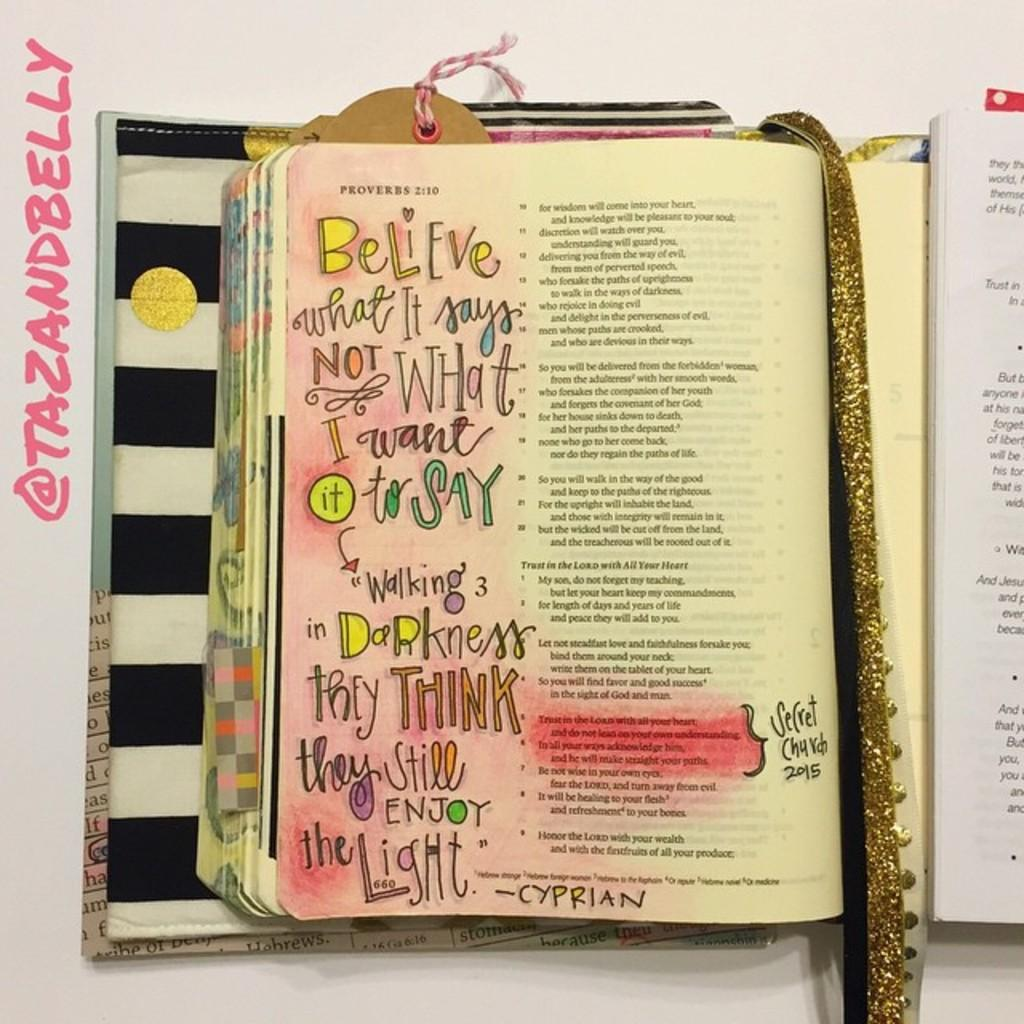<image>
Offer a succinct explanation of the picture presented. A Bible opened to Proverbs 2:10 with enlarged colored text on the left. 